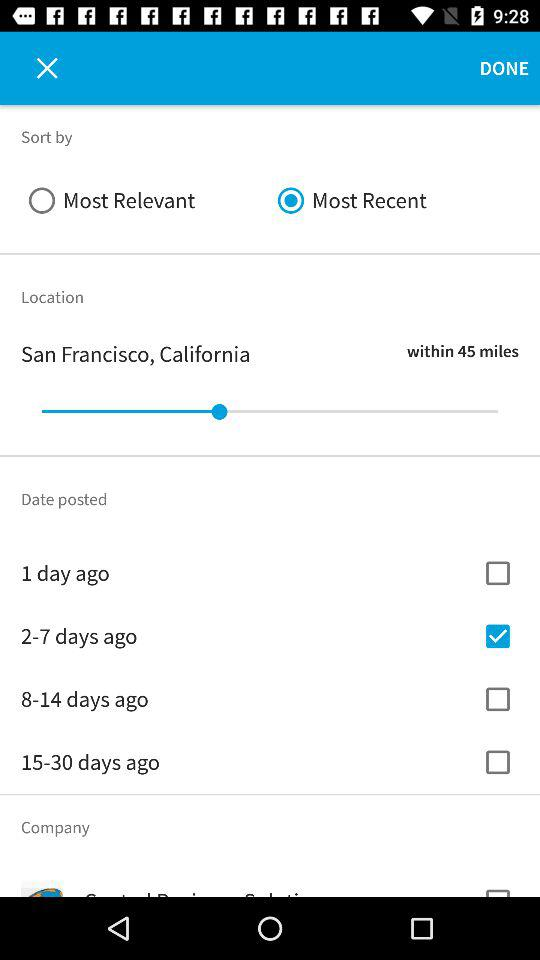Which company is listed?
When the provided information is insufficient, respond with <no answer>. <no answer> 